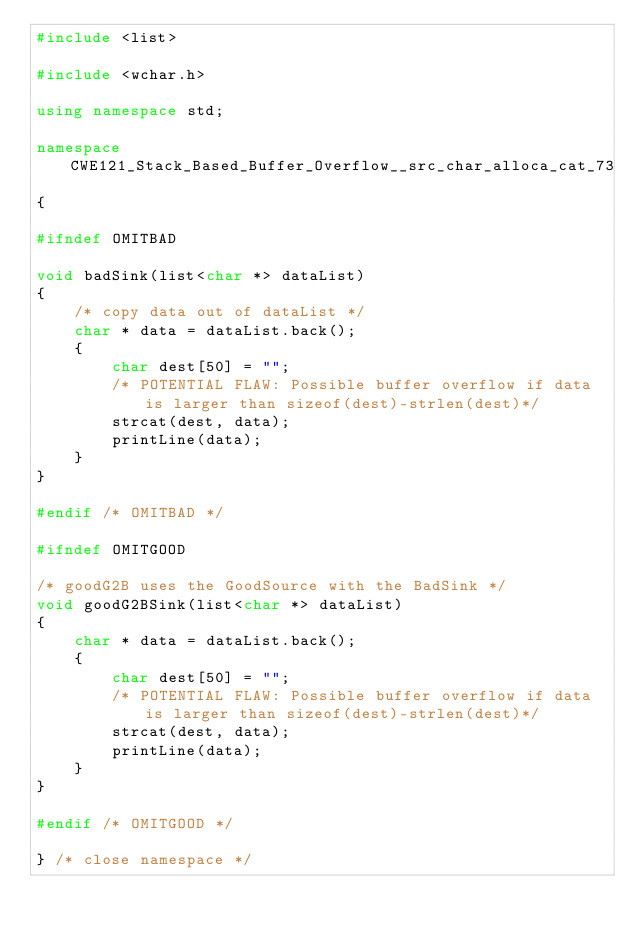Convert code to text. <code><loc_0><loc_0><loc_500><loc_500><_C++_>#include <list>

#include <wchar.h>

using namespace std;

namespace CWE121_Stack_Based_Buffer_Overflow__src_char_alloca_cat_73
{

#ifndef OMITBAD

void badSink(list<char *> dataList)
{
    /* copy data out of dataList */
    char * data = dataList.back();
    {
        char dest[50] = "";
        /* POTENTIAL FLAW: Possible buffer overflow if data is larger than sizeof(dest)-strlen(dest)*/
        strcat(dest, data);
        printLine(data);
    }
}

#endif /* OMITBAD */

#ifndef OMITGOOD

/* goodG2B uses the GoodSource with the BadSink */
void goodG2BSink(list<char *> dataList)
{
    char * data = dataList.back();
    {
        char dest[50] = "";
        /* POTENTIAL FLAW: Possible buffer overflow if data is larger than sizeof(dest)-strlen(dest)*/
        strcat(dest, data);
        printLine(data);
    }
}

#endif /* OMITGOOD */

} /* close namespace */
</code> 